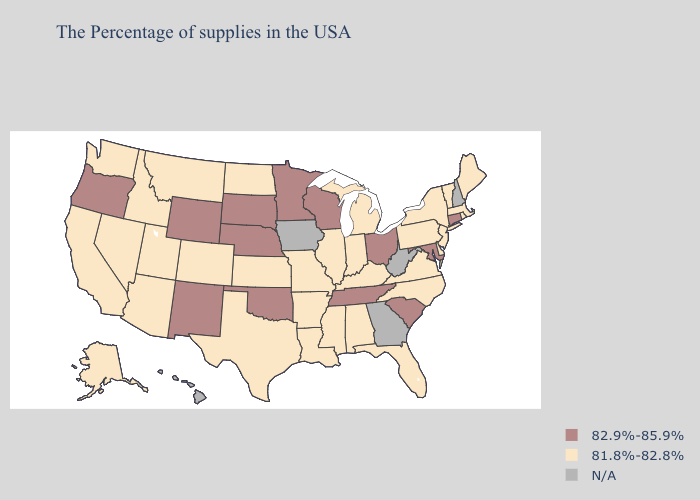Which states have the highest value in the USA?
Answer briefly. Connecticut, Maryland, South Carolina, Ohio, Tennessee, Wisconsin, Minnesota, Nebraska, Oklahoma, South Dakota, Wyoming, New Mexico, Oregon. Name the states that have a value in the range N/A?
Give a very brief answer. New Hampshire, West Virginia, Georgia, Iowa, Hawaii. What is the value of Iowa?
Short answer required. N/A. Does South Carolina have the lowest value in the South?
Write a very short answer. No. Name the states that have a value in the range 81.8%-82.8%?
Concise answer only. Maine, Massachusetts, Rhode Island, Vermont, New York, New Jersey, Delaware, Pennsylvania, Virginia, North Carolina, Florida, Michigan, Kentucky, Indiana, Alabama, Illinois, Mississippi, Louisiana, Missouri, Arkansas, Kansas, Texas, North Dakota, Colorado, Utah, Montana, Arizona, Idaho, Nevada, California, Washington, Alaska. Which states have the highest value in the USA?
Write a very short answer. Connecticut, Maryland, South Carolina, Ohio, Tennessee, Wisconsin, Minnesota, Nebraska, Oklahoma, South Dakota, Wyoming, New Mexico, Oregon. What is the lowest value in the USA?
Short answer required. 81.8%-82.8%. Name the states that have a value in the range N/A?
Be succinct. New Hampshire, West Virginia, Georgia, Iowa, Hawaii. Which states have the lowest value in the West?
Short answer required. Colorado, Utah, Montana, Arizona, Idaho, Nevada, California, Washington, Alaska. Name the states that have a value in the range N/A?
Be succinct. New Hampshire, West Virginia, Georgia, Iowa, Hawaii. Does Nebraska have the lowest value in the MidWest?
Quick response, please. No. Name the states that have a value in the range N/A?
Short answer required. New Hampshire, West Virginia, Georgia, Iowa, Hawaii. Is the legend a continuous bar?
Concise answer only. No. Among the states that border North Dakota , which have the lowest value?
Quick response, please. Montana. What is the highest value in the USA?
Concise answer only. 82.9%-85.9%. 